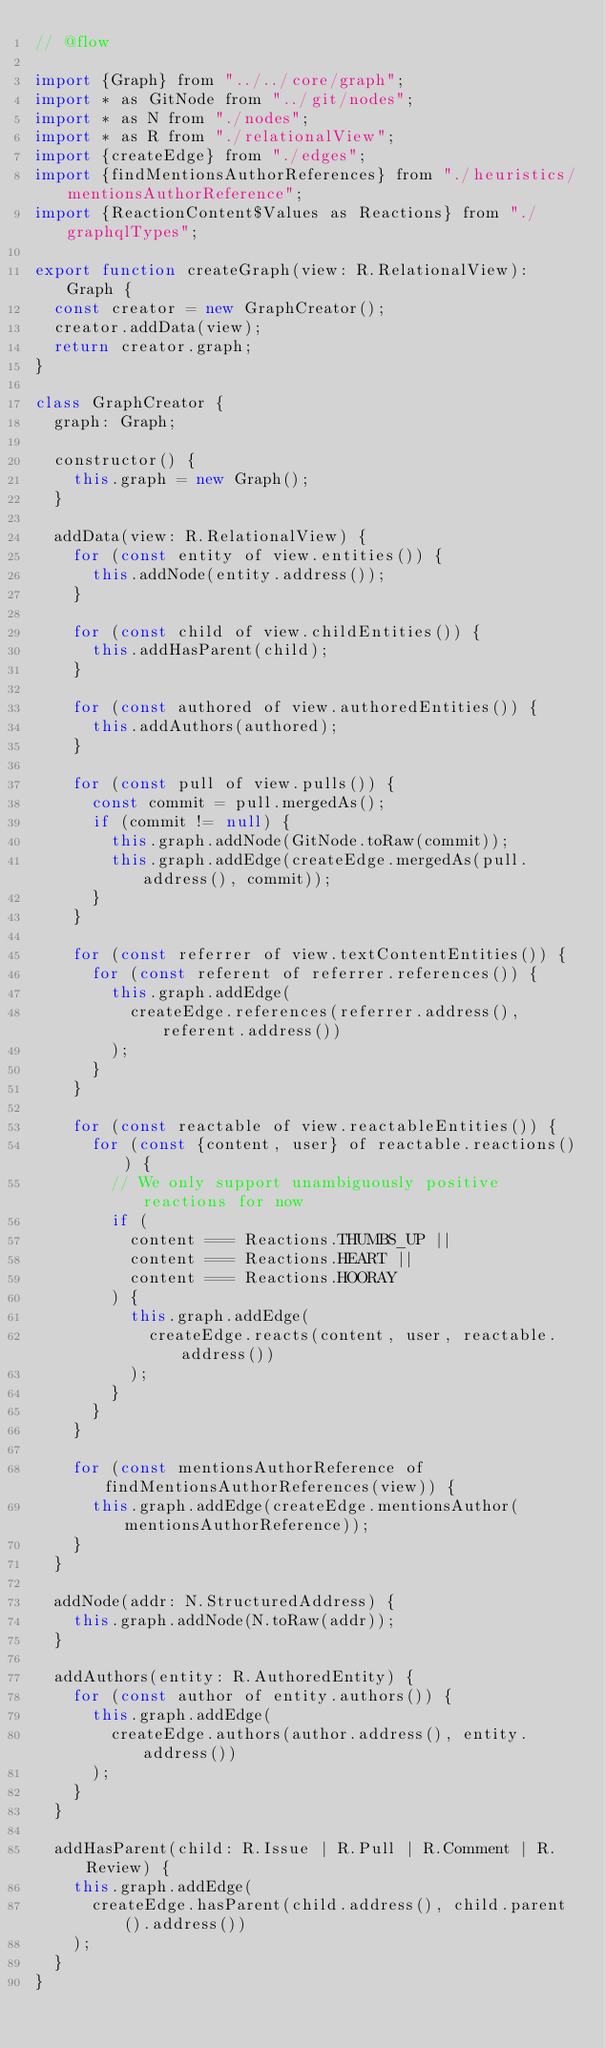Convert code to text. <code><loc_0><loc_0><loc_500><loc_500><_JavaScript_>// @flow

import {Graph} from "../../core/graph";
import * as GitNode from "../git/nodes";
import * as N from "./nodes";
import * as R from "./relationalView";
import {createEdge} from "./edges";
import {findMentionsAuthorReferences} from "./heuristics/mentionsAuthorReference";
import {ReactionContent$Values as Reactions} from "./graphqlTypes";

export function createGraph(view: R.RelationalView): Graph {
  const creator = new GraphCreator();
  creator.addData(view);
  return creator.graph;
}

class GraphCreator {
  graph: Graph;

  constructor() {
    this.graph = new Graph();
  }

  addData(view: R.RelationalView) {
    for (const entity of view.entities()) {
      this.addNode(entity.address());
    }

    for (const child of view.childEntities()) {
      this.addHasParent(child);
    }

    for (const authored of view.authoredEntities()) {
      this.addAuthors(authored);
    }

    for (const pull of view.pulls()) {
      const commit = pull.mergedAs();
      if (commit != null) {
        this.graph.addNode(GitNode.toRaw(commit));
        this.graph.addEdge(createEdge.mergedAs(pull.address(), commit));
      }
    }

    for (const referrer of view.textContentEntities()) {
      for (const referent of referrer.references()) {
        this.graph.addEdge(
          createEdge.references(referrer.address(), referent.address())
        );
      }
    }

    for (const reactable of view.reactableEntities()) {
      for (const {content, user} of reactable.reactions()) {
        // We only support unambiguously positive reactions for now
        if (
          content === Reactions.THUMBS_UP ||
          content === Reactions.HEART ||
          content === Reactions.HOORAY
        ) {
          this.graph.addEdge(
            createEdge.reacts(content, user, reactable.address())
          );
        }
      }
    }

    for (const mentionsAuthorReference of findMentionsAuthorReferences(view)) {
      this.graph.addEdge(createEdge.mentionsAuthor(mentionsAuthorReference));
    }
  }

  addNode(addr: N.StructuredAddress) {
    this.graph.addNode(N.toRaw(addr));
  }

  addAuthors(entity: R.AuthoredEntity) {
    for (const author of entity.authors()) {
      this.graph.addEdge(
        createEdge.authors(author.address(), entity.address())
      );
    }
  }

  addHasParent(child: R.Issue | R.Pull | R.Comment | R.Review) {
    this.graph.addEdge(
      createEdge.hasParent(child.address(), child.parent().address())
    );
  }
}
</code> 